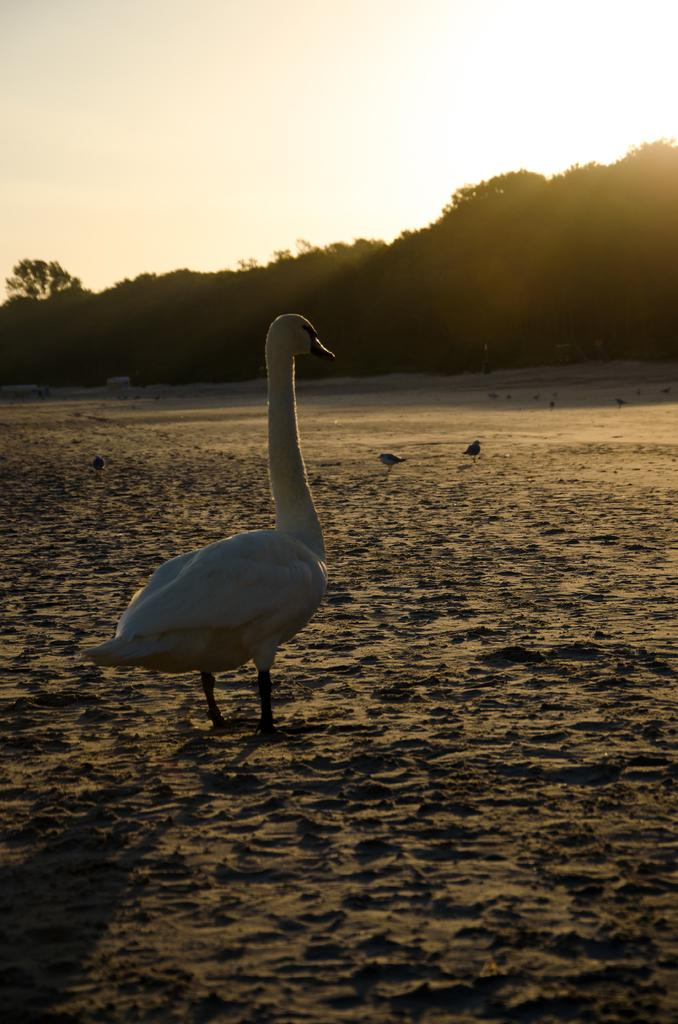What type of animal is in the image? There is a goose in the image. What is the goose standing on in the image? The goose is standing on the sand in the image. What else can be seen on the sand in the image? There are birds on the sand in the image. What can be seen in the background of the image? There are trees and the sky visible in the background of the image. What type of verse can be seen written in the sand in the image? There is no verse written in the sand in the image; it only shows a goose and other birds standing on the sand. 